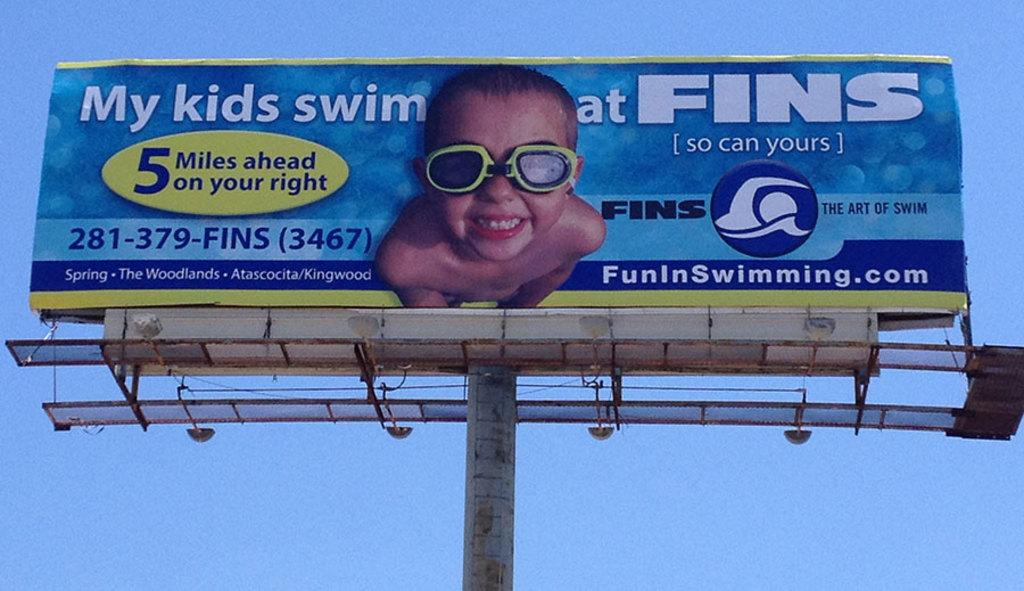<image>
Write a terse but informative summary of the picture. an ad saying my kids swim at fins 